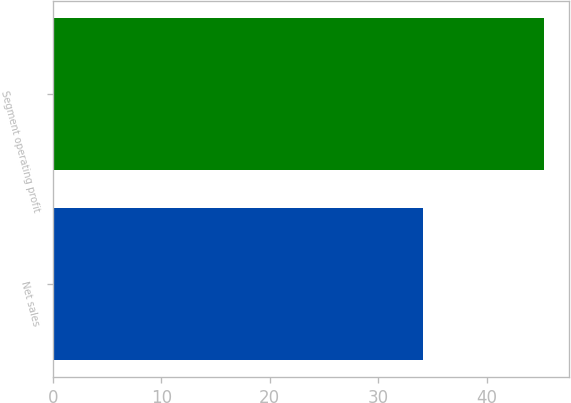Convert chart. <chart><loc_0><loc_0><loc_500><loc_500><bar_chart><fcel>Net sales<fcel>Segment operating profit<nl><fcel>34.1<fcel>45.3<nl></chart> 